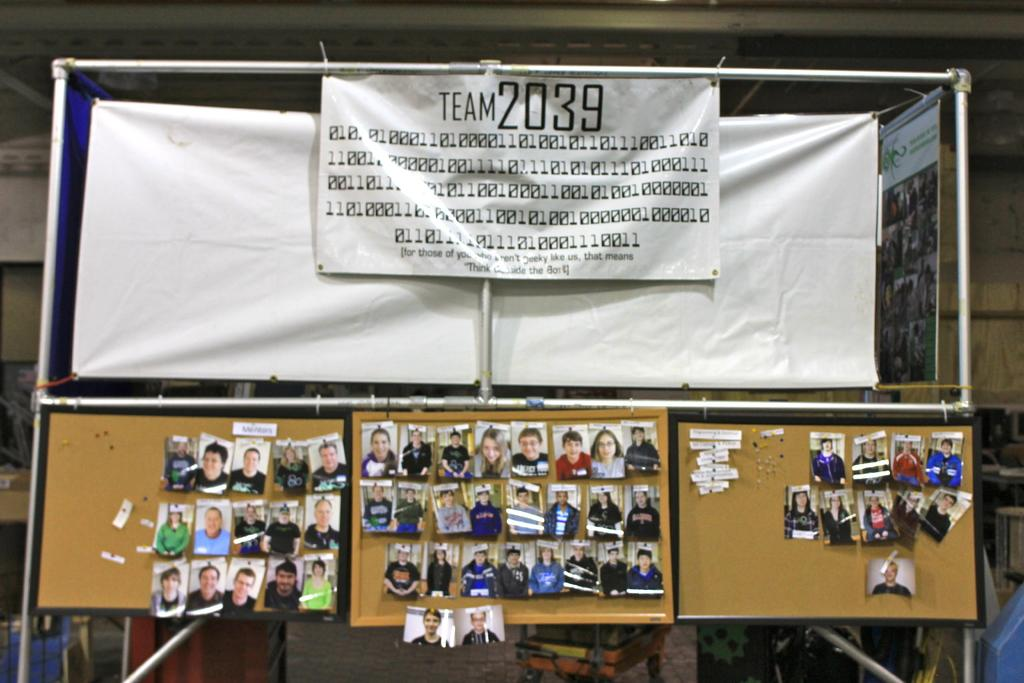<image>
Offer a succinct explanation of the picture presented. Bulletin boards with pictures and a sign that says Team 2039. 